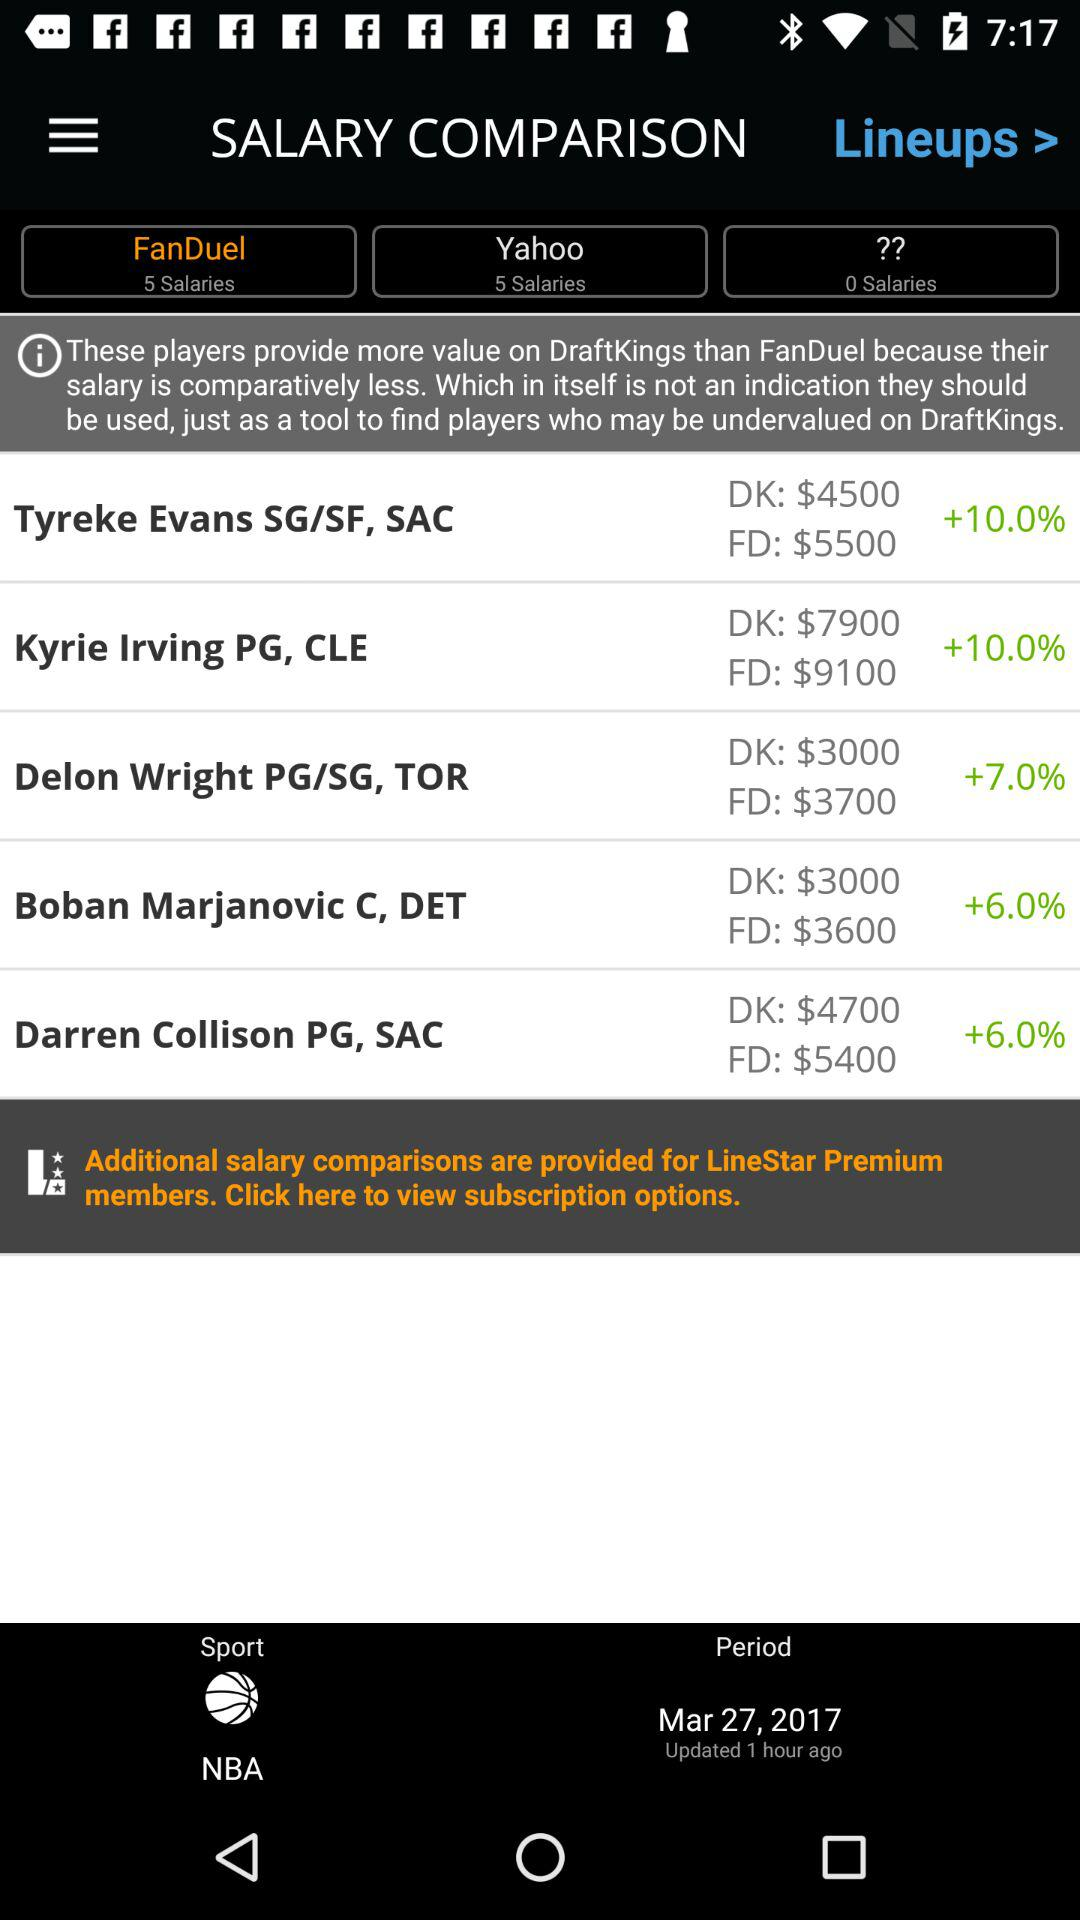What is the increment percentage for Darren Collison? The increment percentage for Darren Collison is 6. 